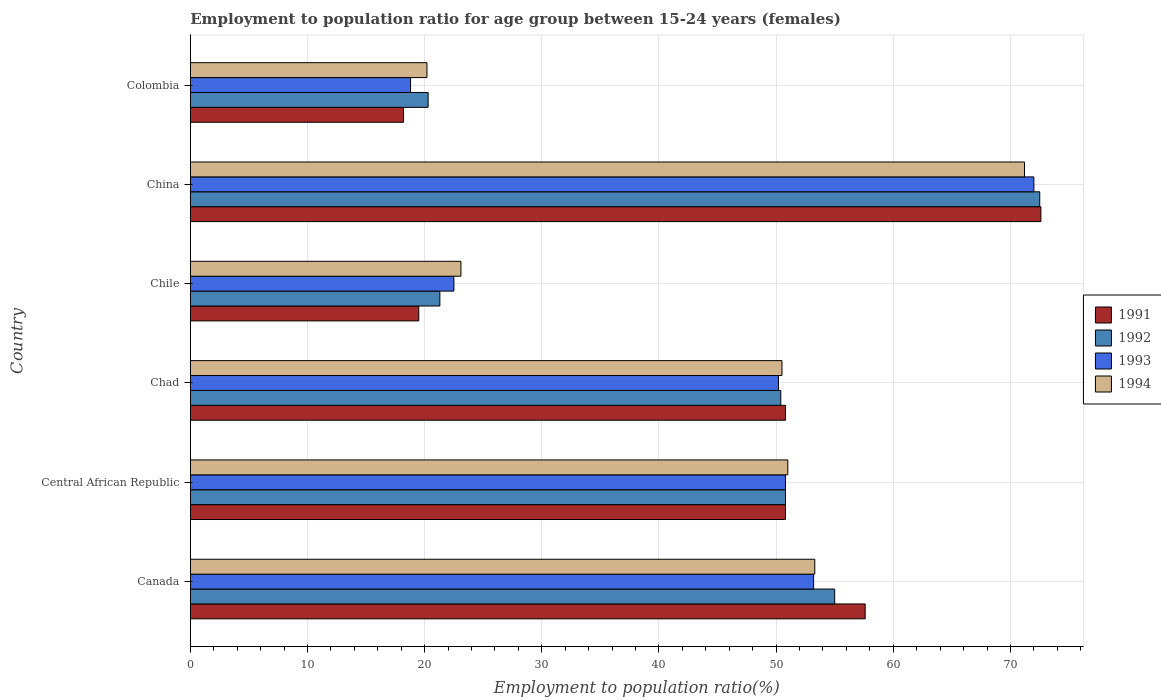Are the number of bars per tick equal to the number of legend labels?
Offer a very short reply. Yes. Are the number of bars on each tick of the Y-axis equal?
Make the answer very short. Yes. How many bars are there on the 6th tick from the bottom?
Provide a short and direct response. 4. What is the employment to population ratio in 1992 in Chad?
Your answer should be compact. 50.4. Across all countries, what is the maximum employment to population ratio in 1993?
Give a very brief answer. 72. Across all countries, what is the minimum employment to population ratio in 1992?
Offer a terse response. 20.3. In which country was the employment to population ratio in 1994 minimum?
Your response must be concise. Colombia. What is the total employment to population ratio in 1993 in the graph?
Provide a short and direct response. 267.5. What is the difference between the employment to population ratio in 1991 in Chad and that in China?
Provide a succinct answer. -21.8. What is the difference between the employment to population ratio in 1992 in Colombia and the employment to population ratio in 1994 in China?
Provide a succinct answer. -50.9. What is the average employment to population ratio in 1993 per country?
Provide a succinct answer. 44.58. What is the difference between the employment to population ratio in 1992 and employment to population ratio in 1993 in Chad?
Ensure brevity in your answer.  0.2. What is the ratio of the employment to population ratio in 1994 in Canada to that in Colombia?
Ensure brevity in your answer.  2.64. Is the difference between the employment to population ratio in 1992 in Chile and Colombia greater than the difference between the employment to population ratio in 1993 in Chile and Colombia?
Your answer should be compact. No. What is the difference between the highest and the second highest employment to population ratio in 1991?
Your answer should be very brief. 15. What is the difference between the highest and the lowest employment to population ratio in 1992?
Keep it short and to the point. 52.2. In how many countries, is the employment to population ratio in 1993 greater than the average employment to population ratio in 1993 taken over all countries?
Offer a terse response. 4. What does the 2nd bar from the top in Chad represents?
Your answer should be very brief. 1993. What does the 3rd bar from the bottom in Colombia represents?
Offer a terse response. 1993. How many bars are there?
Provide a short and direct response. 24. Are all the bars in the graph horizontal?
Offer a very short reply. Yes. What is the difference between two consecutive major ticks on the X-axis?
Make the answer very short. 10. Are the values on the major ticks of X-axis written in scientific E-notation?
Your answer should be very brief. No. Does the graph contain any zero values?
Provide a short and direct response. No. How are the legend labels stacked?
Provide a short and direct response. Vertical. What is the title of the graph?
Your answer should be compact. Employment to population ratio for age group between 15-24 years (females). What is the label or title of the X-axis?
Ensure brevity in your answer.  Employment to population ratio(%). What is the label or title of the Y-axis?
Give a very brief answer. Country. What is the Employment to population ratio(%) of 1991 in Canada?
Offer a terse response. 57.6. What is the Employment to population ratio(%) in 1992 in Canada?
Offer a very short reply. 55. What is the Employment to population ratio(%) of 1993 in Canada?
Give a very brief answer. 53.2. What is the Employment to population ratio(%) in 1994 in Canada?
Provide a short and direct response. 53.3. What is the Employment to population ratio(%) in 1991 in Central African Republic?
Provide a short and direct response. 50.8. What is the Employment to population ratio(%) of 1992 in Central African Republic?
Your response must be concise. 50.8. What is the Employment to population ratio(%) in 1993 in Central African Republic?
Your answer should be compact. 50.8. What is the Employment to population ratio(%) in 1991 in Chad?
Provide a succinct answer. 50.8. What is the Employment to population ratio(%) of 1992 in Chad?
Provide a succinct answer. 50.4. What is the Employment to population ratio(%) in 1993 in Chad?
Your response must be concise. 50.2. What is the Employment to population ratio(%) in 1994 in Chad?
Provide a short and direct response. 50.5. What is the Employment to population ratio(%) of 1992 in Chile?
Keep it short and to the point. 21.3. What is the Employment to population ratio(%) of 1994 in Chile?
Your answer should be very brief. 23.1. What is the Employment to population ratio(%) in 1991 in China?
Keep it short and to the point. 72.6. What is the Employment to population ratio(%) in 1992 in China?
Give a very brief answer. 72.5. What is the Employment to population ratio(%) in 1994 in China?
Keep it short and to the point. 71.2. What is the Employment to population ratio(%) in 1991 in Colombia?
Your answer should be compact. 18.2. What is the Employment to population ratio(%) of 1992 in Colombia?
Provide a short and direct response. 20.3. What is the Employment to population ratio(%) of 1993 in Colombia?
Provide a short and direct response. 18.8. What is the Employment to population ratio(%) of 1994 in Colombia?
Provide a succinct answer. 20.2. Across all countries, what is the maximum Employment to population ratio(%) in 1991?
Ensure brevity in your answer.  72.6. Across all countries, what is the maximum Employment to population ratio(%) of 1992?
Provide a succinct answer. 72.5. Across all countries, what is the maximum Employment to population ratio(%) of 1993?
Provide a succinct answer. 72. Across all countries, what is the maximum Employment to population ratio(%) in 1994?
Offer a very short reply. 71.2. Across all countries, what is the minimum Employment to population ratio(%) in 1991?
Provide a short and direct response. 18.2. Across all countries, what is the minimum Employment to population ratio(%) in 1992?
Your response must be concise. 20.3. Across all countries, what is the minimum Employment to population ratio(%) in 1993?
Your response must be concise. 18.8. Across all countries, what is the minimum Employment to population ratio(%) of 1994?
Ensure brevity in your answer.  20.2. What is the total Employment to population ratio(%) of 1991 in the graph?
Offer a very short reply. 269.5. What is the total Employment to population ratio(%) of 1992 in the graph?
Ensure brevity in your answer.  270.3. What is the total Employment to population ratio(%) in 1993 in the graph?
Ensure brevity in your answer.  267.5. What is the total Employment to population ratio(%) of 1994 in the graph?
Offer a terse response. 269.3. What is the difference between the Employment to population ratio(%) of 1992 in Canada and that in Central African Republic?
Keep it short and to the point. 4.2. What is the difference between the Employment to population ratio(%) in 1994 in Canada and that in Central African Republic?
Give a very brief answer. 2.3. What is the difference between the Employment to population ratio(%) of 1992 in Canada and that in Chad?
Provide a succinct answer. 4.6. What is the difference between the Employment to population ratio(%) of 1993 in Canada and that in Chad?
Your response must be concise. 3. What is the difference between the Employment to population ratio(%) in 1991 in Canada and that in Chile?
Offer a very short reply. 38.1. What is the difference between the Employment to population ratio(%) in 1992 in Canada and that in Chile?
Provide a short and direct response. 33.7. What is the difference between the Employment to population ratio(%) in 1993 in Canada and that in Chile?
Provide a short and direct response. 30.7. What is the difference between the Employment to population ratio(%) in 1994 in Canada and that in Chile?
Make the answer very short. 30.2. What is the difference between the Employment to population ratio(%) of 1991 in Canada and that in China?
Your answer should be very brief. -15. What is the difference between the Employment to population ratio(%) in 1992 in Canada and that in China?
Provide a short and direct response. -17.5. What is the difference between the Employment to population ratio(%) in 1993 in Canada and that in China?
Provide a short and direct response. -18.8. What is the difference between the Employment to population ratio(%) in 1994 in Canada and that in China?
Ensure brevity in your answer.  -17.9. What is the difference between the Employment to population ratio(%) of 1991 in Canada and that in Colombia?
Offer a terse response. 39.4. What is the difference between the Employment to population ratio(%) of 1992 in Canada and that in Colombia?
Keep it short and to the point. 34.7. What is the difference between the Employment to population ratio(%) in 1993 in Canada and that in Colombia?
Offer a terse response. 34.4. What is the difference between the Employment to population ratio(%) of 1994 in Canada and that in Colombia?
Give a very brief answer. 33.1. What is the difference between the Employment to population ratio(%) of 1991 in Central African Republic and that in Chad?
Your answer should be very brief. 0. What is the difference between the Employment to population ratio(%) of 1994 in Central African Republic and that in Chad?
Your answer should be compact. 0.5. What is the difference between the Employment to population ratio(%) in 1991 in Central African Republic and that in Chile?
Ensure brevity in your answer.  31.3. What is the difference between the Employment to population ratio(%) of 1992 in Central African Republic and that in Chile?
Your answer should be very brief. 29.5. What is the difference between the Employment to population ratio(%) in 1993 in Central African Republic and that in Chile?
Your response must be concise. 28.3. What is the difference between the Employment to population ratio(%) of 1994 in Central African Republic and that in Chile?
Offer a very short reply. 27.9. What is the difference between the Employment to population ratio(%) of 1991 in Central African Republic and that in China?
Offer a terse response. -21.8. What is the difference between the Employment to population ratio(%) of 1992 in Central African Republic and that in China?
Provide a succinct answer. -21.7. What is the difference between the Employment to population ratio(%) of 1993 in Central African Republic and that in China?
Your response must be concise. -21.2. What is the difference between the Employment to population ratio(%) of 1994 in Central African Republic and that in China?
Your response must be concise. -20.2. What is the difference between the Employment to population ratio(%) of 1991 in Central African Republic and that in Colombia?
Offer a very short reply. 32.6. What is the difference between the Employment to population ratio(%) in 1992 in Central African Republic and that in Colombia?
Ensure brevity in your answer.  30.5. What is the difference between the Employment to population ratio(%) in 1994 in Central African Republic and that in Colombia?
Give a very brief answer. 30.8. What is the difference between the Employment to population ratio(%) of 1991 in Chad and that in Chile?
Ensure brevity in your answer.  31.3. What is the difference between the Employment to population ratio(%) of 1992 in Chad and that in Chile?
Provide a short and direct response. 29.1. What is the difference between the Employment to population ratio(%) of 1993 in Chad and that in Chile?
Make the answer very short. 27.7. What is the difference between the Employment to population ratio(%) of 1994 in Chad and that in Chile?
Give a very brief answer. 27.4. What is the difference between the Employment to population ratio(%) in 1991 in Chad and that in China?
Offer a terse response. -21.8. What is the difference between the Employment to population ratio(%) in 1992 in Chad and that in China?
Ensure brevity in your answer.  -22.1. What is the difference between the Employment to population ratio(%) in 1993 in Chad and that in China?
Offer a terse response. -21.8. What is the difference between the Employment to population ratio(%) of 1994 in Chad and that in China?
Offer a very short reply. -20.7. What is the difference between the Employment to population ratio(%) in 1991 in Chad and that in Colombia?
Give a very brief answer. 32.6. What is the difference between the Employment to population ratio(%) of 1992 in Chad and that in Colombia?
Provide a succinct answer. 30.1. What is the difference between the Employment to population ratio(%) in 1993 in Chad and that in Colombia?
Provide a succinct answer. 31.4. What is the difference between the Employment to population ratio(%) of 1994 in Chad and that in Colombia?
Your answer should be very brief. 30.3. What is the difference between the Employment to population ratio(%) of 1991 in Chile and that in China?
Your answer should be very brief. -53.1. What is the difference between the Employment to population ratio(%) of 1992 in Chile and that in China?
Provide a short and direct response. -51.2. What is the difference between the Employment to population ratio(%) of 1993 in Chile and that in China?
Your answer should be very brief. -49.5. What is the difference between the Employment to population ratio(%) of 1994 in Chile and that in China?
Your answer should be compact. -48.1. What is the difference between the Employment to population ratio(%) in 1994 in Chile and that in Colombia?
Ensure brevity in your answer.  2.9. What is the difference between the Employment to population ratio(%) in 1991 in China and that in Colombia?
Ensure brevity in your answer.  54.4. What is the difference between the Employment to population ratio(%) of 1992 in China and that in Colombia?
Ensure brevity in your answer.  52.2. What is the difference between the Employment to population ratio(%) in 1993 in China and that in Colombia?
Provide a short and direct response. 53.2. What is the difference between the Employment to population ratio(%) in 1991 in Canada and the Employment to population ratio(%) in 1993 in Central African Republic?
Keep it short and to the point. 6.8. What is the difference between the Employment to population ratio(%) of 1991 in Canada and the Employment to population ratio(%) of 1994 in Central African Republic?
Provide a short and direct response. 6.6. What is the difference between the Employment to population ratio(%) of 1992 in Canada and the Employment to population ratio(%) of 1993 in Central African Republic?
Your answer should be compact. 4.2. What is the difference between the Employment to population ratio(%) of 1992 in Canada and the Employment to population ratio(%) of 1994 in Central African Republic?
Ensure brevity in your answer.  4. What is the difference between the Employment to population ratio(%) of 1993 in Canada and the Employment to population ratio(%) of 1994 in Central African Republic?
Make the answer very short. 2.2. What is the difference between the Employment to population ratio(%) in 1991 in Canada and the Employment to population ratio(%) in 1992 in Chad?
Your answer should be very brief. 7.2. What is the difference between the Employment to population ratio(%) in 1991 in Canada and the Employment to population ratio(%) in 1994 in Chad?
Provide a short and direct response. 7.1. What is the difference between the Employment to population ratio(%) in 1992 in Canada and the Employment to population ratio(%) in 1994 in Chad?
Provide a short and direct response. 4.5. What is the difference between the Employment to population ratio(%) in 1991 in Canada and the Employment to population ratio(%) in 1992 in Chile?
Your answer should be very brief. 36.3. What is the difference between the Employment to population ratio(%) in 1991 in Canada and the Employment to population ratio(%) in 1993 in Chile?
Your response must be concise. 35.1. What is the difference between the Employment to population ratio(%) of 1991 in Canada and the Employment to population ratio(%) of 1994 in Chile?
Offer a terse response. 34.5. What is the difference between the Employment to population ratio(%) in 1992 in Canada and the Employment to population ratio(%) in 1993 in Chile?
Keep it short and to the point. 32.5. What is the difference between the Employment to population ratio(%) in 1992 in Canada and the Employment to population ratio(%) in 1994 in Chile?
Offer a very short reply. 31.9. What is the difference between the Employment to population ratio(%) in 1993 in Canada and the Employment to population ratio(%) in 1994 in Chile?
Keep it short and to the point. 30.1. What is the difference between the Employment to population ratio(%) of 1991 in Canada and the Employment to population ratio(%) of 1992 in China?
Provide a succinct answer. -14.9. What is the difference between the Employment to population ratio(%) of 1991 in Canada and the Employment to population ratio(%) of 1993 in China?
Keep it short and to the point. -14.4. What is the difference between the Employment to population ratio(%) in 1992 in Canada and the Employment to population ratio(%) in 1993 in China?
Offer a very short reply. -17. What is the difference between the Employment to population ratio(%) in 1992 in Canada and the Employment to population ratio(%) in 1994 in China?
Your response must be concise. -16.2. What is the difference between the Employment to population ratio(%) of 1993 in Canada and the Employment to population ratio(%) of 1994 in China?
Make the answer very short. -18. What is the difference between the Employment to population ratio(%) of 1991 in Canada and the Employment to population ratio(%) of 1992 in Colombia?
Make the answer very short. 37.3. What is the difference between the Employment to population ratio(%) in 1991 in Canada and the Employment to population ratio(%) in 1993 in Colombia?
Give a very brief answer. 38.8. What is the difference between the Employment to population ratio(%) in 1991 in Canada and the Employment to population ratio(%) in 1994 in Colombia?
Make the answer very short. 37.4. What is the difference between the Employment to population ratio(%) in 1992 in Canada and the Employment to population ratio(%) in 1993 in Colombia?
Ensure brevity in your answer.  36.2. What is the difference between the Employment to population ratio(%) in 1992 in Canada and the Employment to population ratio(%) in 1994 in Colombia?
Provide a succinct answer. 34.8. What is the difference between the Employment to population ratio(%) of 1991 in Central African Republic and the Employment to population ratio(%) of 1992 in Chad?
Offer a terse response. 0.4. What is the difference between the Employment to population ratio(%) in 1991 in Central African Republic and the Employment to population ratio(%) in 1993 in Chad?
Keep it short and to the point. 0.6. What is the difference between the Employment to population ratio(%) in 1991 in Central African Republic and the Employment to population ratio(%) in 1994 in Chad?
Give a very brief answer. 0.3. What is the difference between the Employment to population ratio(%) in 1992 in Central African Republic and the Employment to population ratio(%) in 1994 in Chad?
Provide a short and direct response. 0.3. What is the difference between the Employment to population ratio(%) of 1991 in Central African Republic and the Employment to population ratio(%) of 1992 in Chile?
Offer a very short reply. 29.5. What is the difference between the Employment to population ratio(%) of 1991 in Central African Republic and the Employment to population ratio(%) of 1993 in Chile?
Offer a very short reply. 28.3. What is the difference between the Employment to population ratio(%) in 1991 in Central African Republic and the Employment to population ratio(%) in 1994 in Chile?
Provide a short and direct response. 27.7. What is the difference between the Employment to population ratio(%) of 1992 in Central African Republic and the Employment to population ratio(%) of 1993 in Chile?
Give a very brief answer. 28.3. What is the difference between the Employment to population ratio(%) in 1992 in Central African Republic and the Employment to population ratio(%) in 1994 in Chile?
Give a very brief answer. 27.7. What is the difference between the Employment to population ratio(%) of 1993 in Central African Republic and the Employment to population ratio(%) of 1994 in Chile?
Make the answer very short. 27.7. What is the difference between the Employment to population ratio(%) in 1991 in Central African Republic and the Employment to population ratio(%) in 1992 in China?
Offer a terse response. -21.7. What is the difference between the Employment to population ratio(%) in 1991 in Central African Republic and the Employment to population ratio(%) in 1993 in China?
Make the answer very short. -21.2. What is the difference between the Employment to population ratio(%) of 1991 in Central African Republic and the Employment to population ratio(%) of 1994 in China?
Provide a succinct answer. -20.4. What is the difference between the Employment to population ratio(%) of 1992 in Central African Republic and the Employment to population ratio(%) of 1993 in China?
Provide a short and direct response. -21.2. What is the difference between the Employment to population ratio(%) of 1992 in Central African Republic and the Employment to population ratio(%) of 1994 in China?
Provide a succinct answer. -20.4. What is the difference between the Employment to population ratio(%) in 1993 in Central African Republic and the Employment to population ratio(%) in 1994 in China?
Your answer should be very brief. -20.4. What is the difference between the Employment to population ratio(%) of 1991 in Central African Republic and the Employment to population ratio(%) of 1992 in Colombia?
Offer a terse response. 30.5. What is the difference between the Employment to population ratio(%) of 1991 in Central African Republic and the Employment to population ratio(%) of 1993 in Colombia?
Provide a succinct answer. 32. What is the difference between the Employment to population ratio(%) in 1991 in Central African Republic and the Employment to population ratio(%) in 1994 in Colombia?
Your answer should be compact. 30.6. What is the difference between the Employment to population ratio(%) in 1992 in Central African Republic and the Employment to population ratio(%) in 1994 in Colombia?
Ensure brevity in your answer.  30.6. What is the difference between the Employment to population ratio(%) in 1993 in Central African Republic and the Employment to population ratio(%) in 1994 in Colombia?
Your response must be concise. 30.6. What is the difference between the Employment to population ratio(%) of 1991 in Chad and the Employment to population ratio(%) of 1992 in Chile?
Your answer should be compact. 29.5. What is the difference between the Employment to population ratio(%) in 1991 in Chad and the Employment to population ratio(%) in 1993 in Chile?
Your response must be concise. 28.3. What is the difference between the Employment to population ratio(%) in 1991 in Chad and the Employment to population ratio(%) in 1994 in Chile?
Give a very brief answer. 27.7. What is the difference between the Employment to population ratio(%) in 1992 in Chad and the Employment to population ratio(%) in 1993 in Chile?
Your answer should be very brief. 27.9. What is the difference between the Employment to population ratio(%) in 1992 in Chad and the Employment to population ratio(%) in 1994 in Chile?
Your answer should be very brief. 27.3. What is the difference between the Employment to population ratio(%) of 1993 in Chad and the Employment to population ratio(%) of 1994 in Chile?
Offer a terse response. 27.1. What is the difference between the Employment to population ratio(%) of 1991 in Chad and the Employment to population ratio(%) of 1992 in China?
Make the answer very short. -21.7. What is the difference between the Employment to population ratio(%) in 1991 in Chad and the Employment to population ratio(%) in 1993 in China?
Offer a terse response. -21.2. What is the difference between the Employment to population ratio(%) in 1991 in Chad and the Employment to population ratio(%) in 1994 in China?
Provide a short and direct response. -20.4. What is the difference between the Employment to population ratio(%) in 1992 in Chad and the Employment to population ratio(%) in 1993 in China?
Give a very brief answer. -21.6. What is the difference between the Employment to population ratio(%) in 1992 in Chad and the Employment to population ratio(%) in 1994 in China?
Offer a very short reply. -20.8. What is the difference between the Employment to population ratio(%) in 1993 in Chad and the Employment to population ratio(%) in 1994 in China?
Make the answer very short. -21. What is the difference between the Employment to population ratio(%) of 1991 in Chad and the Employment to population ratio(%) of 1992 in Colombia?
Make the answer very short. 30.5. What is the difference between the Employment to population ratio(%) in 1991 in Chad and the Employment to population ratio(%) in 1993 in Colombia?
Your answer should be compact. 32. What is the difference between the Employment to population ratio(%) of 1991 in Chad and the Employment to population ratio(%) of 1994 in Colombia?
Your response must be concise. 30.6. What is the difference between the Employment to population ratio(%) of 1992 in Chad and the Employment to population ratio(%) of 1993 in Colombia?
Make the answer very short. 31.6. What is the difference between the Employment to population ratio(%) in 1992 in Chad and the Employment to population ratio(%) in 1994 in Colombia?
Make the answer very short. 30.2. What is the difference between the Employment to population ratio(%) in 1991 in Chile and the Employment to population ratio(%) in 1992 in China?
Your answer should be very brief. -53. What is the difference between the Employment to population ratio(%) of 1991 in Chile and the Employment to population ratio(%) of 1993 in China?
Offer a very short reply. -52.5. What is the difference between the Employment to population ratio(%) in 1991 in Chile and the Employment to population ratio(%) in 1994 in China?
Your response must be concise. -51.7. What is the difference between the Employment to population ratio(%) of 1992 in Chile and the Employment to population ratio(%) of 1993 in China?
Your response must be concise. -50.7. What is the difference between the Employment to population ratio(%) of 1992 in Chile and the Employment to population ratio(%) of 1994 in China?
Keep it short and to the point. -49.9. What is the difference between the Employment to population ratio(%) in 1993 in Chile and the Employment to population ratio(%) in 1994 in China?
Give a very brief answer. -48.7. What is the difference between the Employment to population ratio(%) of 1991 in Chile and the Employment to population ratio(%) of 1993 in Colombia?
Your answer should be compact. 0.7. What is the difference between the Employment to population ratio(%) of 1992 in Chile and the Employment to population ratio(%) of 1993 in Colombia?
Your answer should be compact. 2.5. What is the difference between the Employment to population ratio(%) in 1992 in Chile and the Employment to population ratio(%) in 1994 in Colombia?
Provide a succinct answer. 1.1. What is the difference between the Employment to population ratio(%) of 1993 in Chile and the Employment to population ratio(%) of 1994 in Colombia?
Give a very brief answer. 2.3. What is the difference between the Employment to population ratio(%) of 1991 in China and the Employment to population ratio(%) of 1992 in Colombia?
Offer a terse response. 52.3. What is the difference between the Employment to population ratio(%) of 1991 in China and the Employment to population ratio(%) of 1993 in Colombia?
Your answer should be compact. 53.8. What is the difference between the Employment to population ratio(%) in 1991 in China and the Employment to population ratio(%) in 1994 in Colombia?
Offer a very short reply. 52.4. What is the difference between the Employment to population ratio(%) of 1992 in China and the Employment to population ratio(%) of 1993 in Colombia?
Ensure brevity in your answer.  53.7. What is the difference between the Employment to population ratio(%) of 1992 in China and the Employment to population ratio(%) of 1994 in Colombia?
Give a very brief answer. 52.3. What is the difference between the Employment to population ratio(%) in 1993 in China and the Employment to population ratio(%) in 1994 in Colombia?
Your answer should be compact. 51.8. What is the average Employment to population ratio(%) of 1991 per country?
Provide a succinct answer. 44.92. What is the average Employment to population ratio(%) in 1992 per country?
Provide a succinct answer. 45.05. What is the average Employment to population ratio(%) of 1993 per country?
Make the answer very short. 44.58. What is the average Employment to population ratio(%) in 1994 per country?
Ensure brevity in your answer.  44.88. What is the difference between the Employment to population ratio(%) in 1991 and Employment to population ratio(%) in 1993 in Canada?
Your answer should be very brief. 4.4. What is the difference between the Employment to population ratio(%) of 1991 and Employment to population ratio(%) of 1994 in Canada?
Your answer should be very brief. 4.3. What is the difference between the Employment to population ratio(%) in 1992 and Employment to population ratio(%) in 1993 in Canada?
Provide a succinct answer. 1.8. What is the difference between the Employment to population ratio(%) of 1991 and Employment to population ratio(%) of 1992 in Central African Republic?
Offer a very short reply. 0. What is the difference between the Employment to population ratio(%) of 1992 and Employment to population ratio(%) of 1993 in Central African Republic?
Give a very brief answer. 0. What is the difference between the Employment to population ratio(%) in 1993 and Employment to population ratio(%) in 1994 in Central African Republic?
Ensure brevity in your answer.  -0.2. What is the difference between the Employment to population ratio(%) in 1992 and Employment to population ratio(%) in 1994 in Chad?
Give a very brief answer. -0.1. What is the difference between the Employment to population ratio(%) of 1991 and Employment to population ratio(%) of 1992 in Chile?
Your response must be concise. -1.8. What is the difference between the Employment to population ratio(%) of 1991 and Employment to population ratio(%) of 1993 in Chile?
Offer a very short reply. -3. What is the difference between the Employment to population ratio(%) of 1992 and Employment to population ratio(%) of 1993 in Chile?
Offer a very short reply. -1.2. What is the difference between the Employment to population ratio(%) of 1993 and Employment to population ratio(%) of 1994 in Chile?
Ensure brevity in your answer.  -0.6. What is the difference between the Employment to population ratio(%) of 1991 and Employment to population ratio(%) of 1992 in China?
Offer a terse response. 0.1. What is the difference between the Employment to population ratio(%) of 1992 and Employment to population ratio(%) of 1993 in China?
Keep it short and to the point. 0.5. What is the difference between the Employment to population ratio(%) of 1992 and Employment to population ratio(%) of 1994 in China?
Your response must be concise. 1.3. What is the difference between the Employment to population ratio(%) in 1993 and Employment to population ratio(%) in 1994 in China?
Keep it short and to the point. 0.8. What is the difference between the Employment to population ratio(%) in 1991 and Employment to population ratio(%) in 1992 in Colombia?
Give a very brief answer. -2.1. What is the difference between the Employment to population ratio(%) in 1991 and Employment to population ratio(%) in 1993 in Colombia?
Your answer should be compact. -0.6. What is the difference between the Employment to population ratio(%) of 1991 and Employment to population ratio(%) of 1994 in Colombia?
Offer a very short reply. -2. What is the difference between the Employment to population ratio(%) of 1992 and Employment to population ratio(%) of 1993 in Colombia?
Your answer should be compact. 1.5. What is the ratio of the Employment to population ratio(%) of 1991 in Canada to that in Central African Republic?
Ensure brevity in your answer.  1.13. What is the ratio of the Employment to population ratio(%) in 1992 in Canada to that in Central African Republic?
Your response must be concise. 1.08. What is the ratio of the Employment to population ratio(%) of 1993 in Canada to that in Central African Republic?
Offer a very short reply. 1.05. What is the ratio of the Employment to population ratio(%) of 1994 in Canada to that in Central African Republic?
Offer a very short reply. 1.05. What is the ratio of the Employment to population ratio(%) of 1991 in Canada to that in Chad?
Provide a short and direct response. 1.13. What is the ratio of the Employment to population ratio(%) of 1992 in Canada to that in Chad?
Your answer should be very brief. 1.09. What is the ratio of the Employment to population ratio(%) in 1993 in Canada to that in Chad?
Offer a very short reply. 1.06. What is the ratio of the Employment to population ratio(%) of 1994 in Canada to that in Chad?
Keep it short and to the point. 1.06. What is the ratio of the Employment to population ratio(%) of 1991 in Canada to that in Chile?
Offer a terse response. 2.95. What is the ratio of the Employment to population ratio(%) of 1992 in Canada to that in Chile?
Offer a very short reply. 2.58. What is the ratio of the Employment to population ratio(%) of 1993 in Canada to that in Chile?
Offer a very short reply. 2.36. What is the ratio of the Employment to population ratio(%) of 1994 in Canada to that in Chile?
Keep it short and to the point. 2.31. What is the ratio of the Employment to population ratio(%) in 1991 in Canada to that in China?
Ensure brevity in your answer.  0.79. What is the ratio of the Employment to population ratio(%) of 1992 in Canada to that in China?
Provide a succinct answer. 0.76. What is the ratio of the Employment to population ratio(%) of 1993 in Canada to that in China?
Ensure brevity in your answer.  0.74. What is the ratio of the Employment to population ratio(%) in 1994 in Canada to that in China?
Ensure brevity in your answer.  0.75. What is the ratio of the Employment to population ratio(%) in 1991 in Canada to that in Colombia?
Your response must be concise. 3.16. What is the ratio of the Employment to population ratio(%) of 1992 in Canada to that in Colombia?
Offer a very short reply. 2.71. What is the ratio of the Employment to population ratio(%) of 1993 in Canada to that in Colombia?
Your answer should be very brief. 2.83. What is the ratio of the Employment to population ratio(%) of 1994 in Canada to that in Colombia?
Offer a very short reply. 2.64. What is the ratio of the Employment to population ratio(%) of 1991 in Central African Republic to that in Chad?
Your answer should be very brief. 1. What is the ratio of the Employment to population ratio(%) of 1992 in Central African Republic to that in Chad?
Offer a terse response. 1.01. What is the ratio of the Employment to population ratio(%) in 1994 in Central African Republic to that in Chad?
Give a very brief answer. 1.01. What is the ratio of the Employment to population ratio(%) in 1991 in Central African Republic to that in Chile?
Give a very brief answer. 2.61. What is the ratio of the Employment to population ratio(%) of 1992 in Central African Republic to that in Chile?
Your answer should be very brief. 2.38. What is the ratio of the Employment to population ratio(%) in 1993 in Central African Republic to that in Chile?
Offer a terse response. 2.26. What is the ratio of the Employment to population ratio(%) in 1994 in Central African Republic to that in Chile?
Your answer should be very brief. 2.21. What is the ratio of the Employment to population ratio(%) of 1991 in Central African Republic to that in China?
Your response must be concise. 0.7. What is the ratio of the Employment to population ratio(%) in 1992 in Central African Republic to that in China?
Provide a succinct answer. 0.7. What is the ratio of the Employment to population ratio(%) in 1993 in Central African Republic to that in China?
Offer a terse response. 0.71. What is the ratio of the Employment to population ratio(%) in 1994 in Central African Republic to that in China?
Offer a terse response. 0.72. What is the ratio of the Employment to population ratio(%) in 1991 in Central African Republic to that in Colombia?
Offer a very short reply. 2.79. What is the ratio of the Employment to population ratio(%) in 1992 in Central African Republic to that in Colombia?
Provide a short and direct response. 2.5. What is the ratio of the Employment to population ratio(%) in 1993 in Central African Republic to that in Colombia?
Your response must be concise. 2.7. What is the ratio of the Employment to population ratio(%) of 1994 in Central African Republic to that in Colombia?
Your answer should be compact. 2.52. What is the ratio of the Employment to population ratio(%) in 1991 in Chad to that in Chile?
Offer a terse response. 2.61. What is the ratio of the Employment to population ratio(%) of 1992 in Chad to that in Chile?
Give a very brief answer. 2.37. What is the ratio of the Employment to population ratio(%) in 1993 in Chad to that in Chile?
Your answer should be compact. 2.23. What is the ratio of the Employment to population ratio(%) in 1994 in Chad to that in Chile?
Your response must be concise. 2.19. What is the ratio of the Employment to population ratio(%) in 1991 in Chad to that in China?
Provide a succinct answer. 0.7. What is the ratio of the Employment to population ratio(%) of 1992 in Chad to that in China?
Offer a terse response. 0.7. What is the ratio of the Employment to population ratio(%) of 1993 in Chad to that in China?
Keep it short and to the point. 0.7. What is the ratio of the Employment to population ratio(%) of 1994 in Chad to that in China?
Your answer should be compact. 0.71. What is the ratio of the Employment to population ratio(%) of 1991 in Chad to that in Colombia?
Offer a very short reply. 2.79. What is the ratio of the Employment to population ratio(%) in 1992 in Chad to that in Colombia?
Your answer should be very brief. 2.48. What is the ratio of the Employment to population ratio(%) of 1993 in Chad to that in Colombia?
Offer a terse response. 2.67. What is the ratio of the Employment to population ratio(%) of 1991 in Chile to that in China?
Offer a very short reply. 0.27. What is the ratio of the Employment to population ratio(%) in 1992 in Chile to that in China?
Your answer should be compact. 0.29. What is the ratio of the Employment to population ratio(%) of 1993 in Chile to that in China?
Provide a succinct answer. 0.31. What is the ratio of the Employment to population ratio(%) in 1994 in Chile to that in China?
Provide a short and direct response. 0.32. What is the ratio of the Employment to population ratio(%) in 1991 in Chile to that in Colombia?
Offer a terse response. 1.07. What is the ratio of the Employment to population ratio(%) in 1992 in Chile to that in Colombia?
Offer a terse response. 1.05. What is the ratio of the Employment to population ratio(%) of 1993 in Chile to that in Colombia?
Ensure brevity in your answer.  1.2. What is the ratio of the Employment to population ratio(%) of 1994 in Chile to that in Colombia?
Provide a succinct answer. 1.14. What is the ratio of the Employment to population ratio(%) in 1991 in China to that in Colombia?
Your response must be concise. 3.99. What is the ratio of the Employment to population ratio(%) in 1992 in China to that in Colombia?
Give a very brief answer. 3.57. What is the ratio of the Employment to population ratio(%) of 1993 in China to that in Colombia?
Offer a very short reply. 3.83. What is the ratio of the Employment to population ratio(%) in 1994 in China to that in Colombia?
Make the answer very short. 3.52. What is the difference between the highest and the second highest Employment to population ratio(%) of 1991?
Give a very brief answer. 15. What is the difference between the highest and the second highest Employment to population ratio(%) in 1993?
Your answer should be very brief. 18.8. What is the difference between the highest and the second highest Employment to population ratio(%) in 1994?
Offer a terse response. 17.9. What is the difference between the highest and the lowest Employment to population ratio(%) of 1991?
Make the answer very short. 54.4. What is the difference between the highest and the lowest Employment to population ratio(%) in 1992?
Provide a succinct answer. 52.2. What is the difference between the highest and the lowest Employment to population ratio(%) in 1993?
Keep it short and to the point. 53.2. What is the difference between the highest and the lowest Employment to population ratio(%) of 1994?
Provide a short and direct response. 51. 